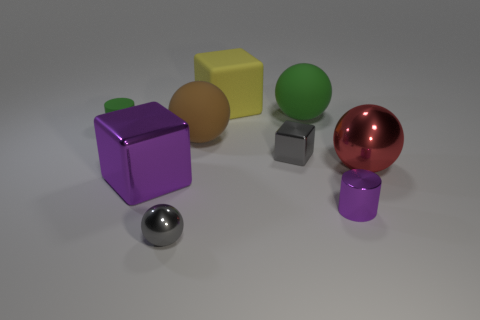Subtract all large brown rubber spheres. How many spheres are left? 3 Add 1 small gray rubber spheres. How many objects exist? 10 Subtract all gray spheres. How many spheres are left? 3 Subtract 1 cubes. How many cubes are left? 2 Subtract all green cubes. Subtract all yellow spheres. How many cubes are left? 3 Subtract 0 brown cylinders. How many objects are left? 9 Subtract all spheres. How many objects are left? 5 Subtract all large red metal balls. Subtract all tiny things. How many objects are left? 4 Add 2 tiny matte things. How many tiny matte things are left? 3 Add 3 blue cubes. How many blue cubes exist? 3 